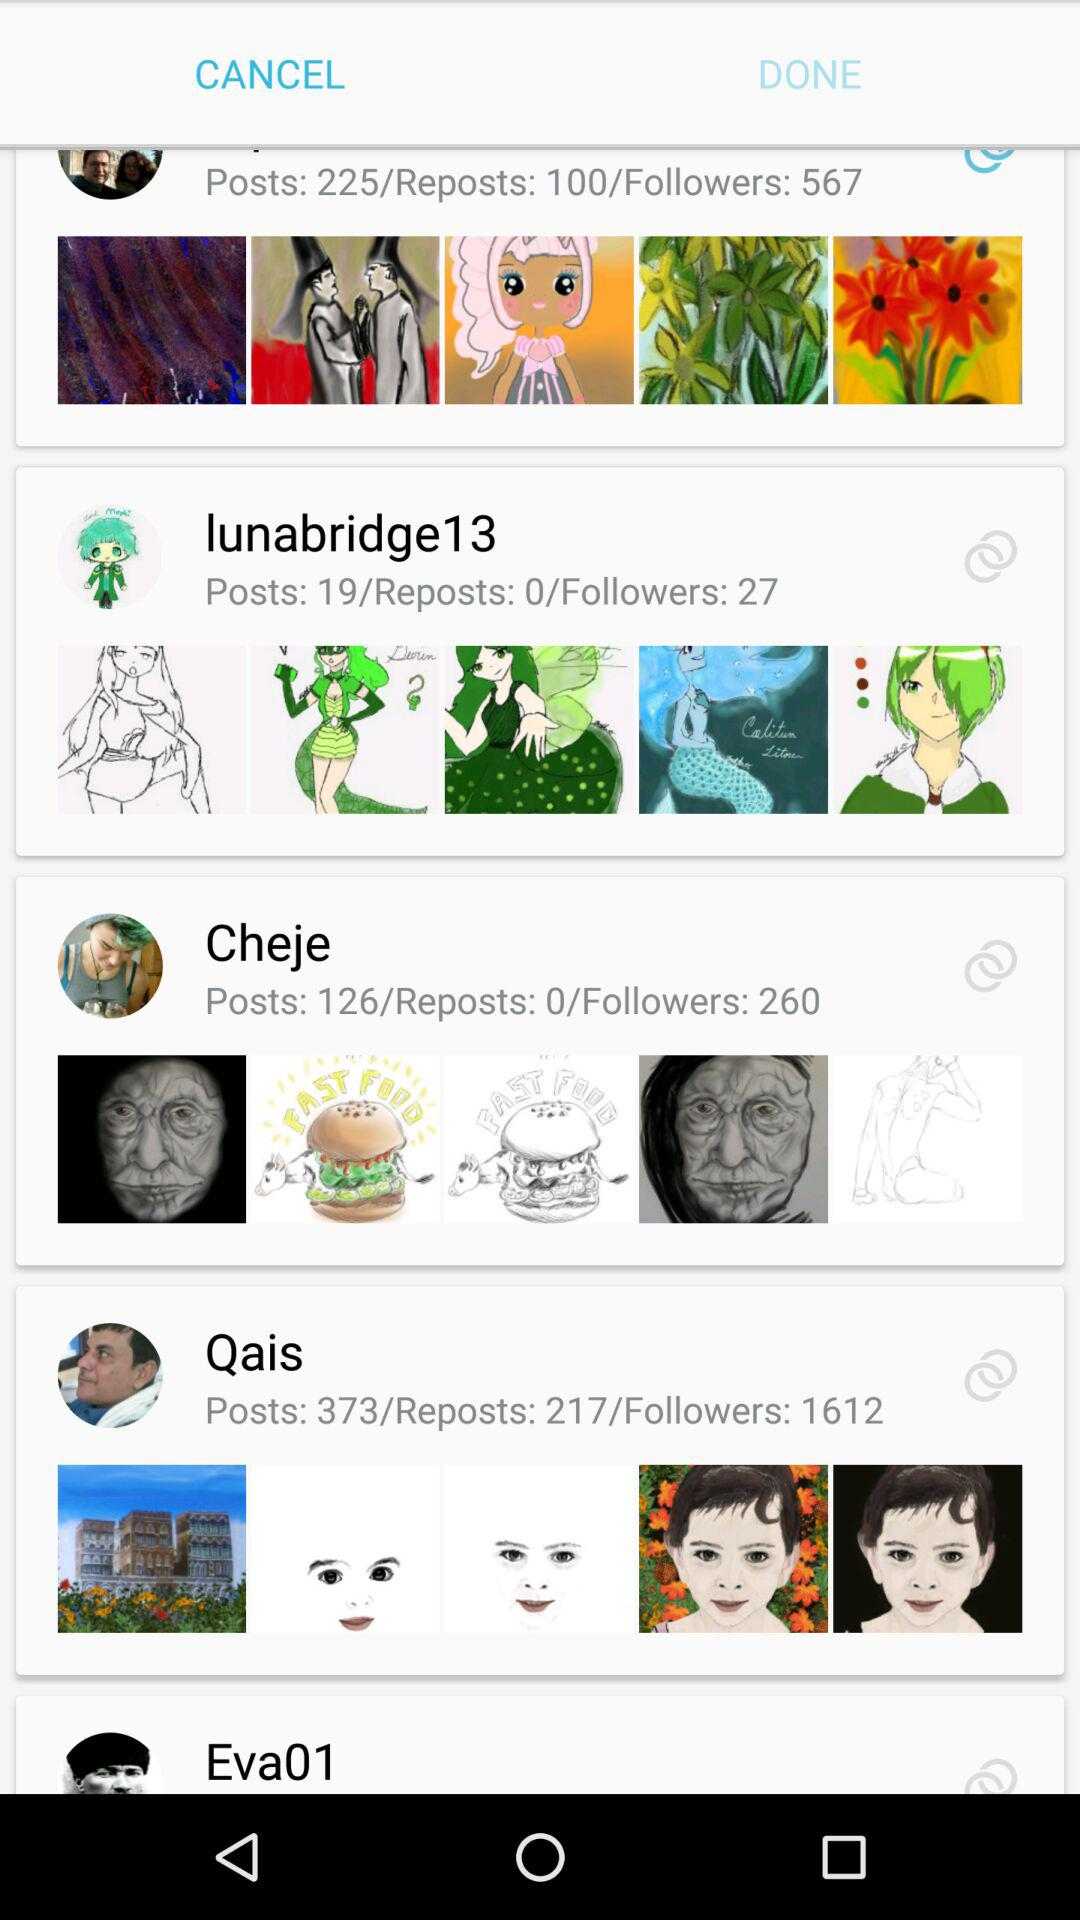How many reposts did Qais do? Qais did 217 reposts. 